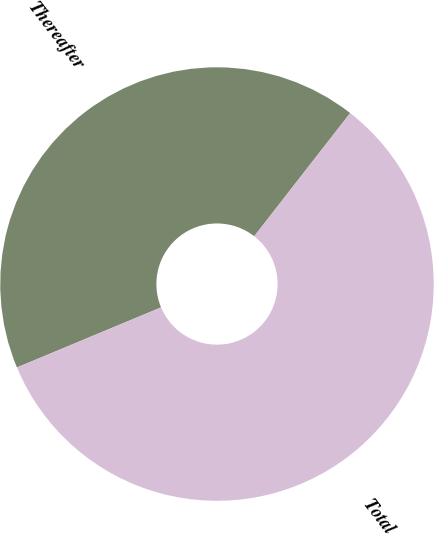Convert chart. <chart><loc_0><loc_0><loc_500><loc_500><pie_chart><fcel>Thereafter<fcel>Total<nl><fcel>41.82%<fcel>58.18%<nl></chart> 